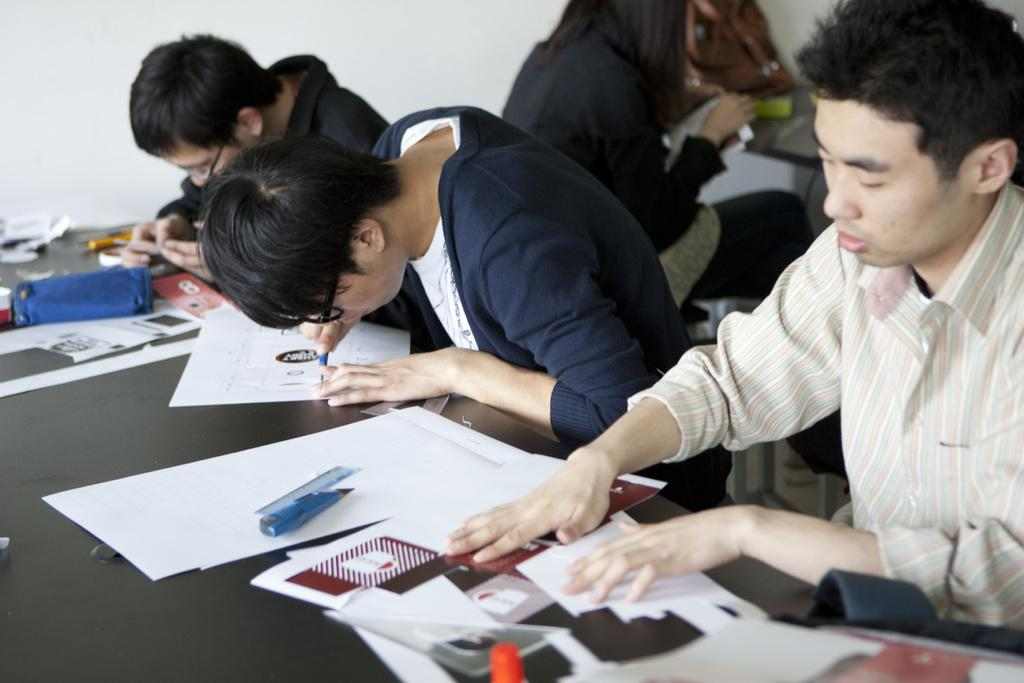Who or what is present in the image? There are people in the image. What can be seen on the tables in the image? There are tables with objects in the image, including papers and scales. What is the background of the image like? There is a wall visible in the image. Are there any additional items on the tables? Yes, there is a bag on one of the tables. What type of bells can be heard ringing in the image? There are no bells present in the image, and therefore no sound can be heard. 